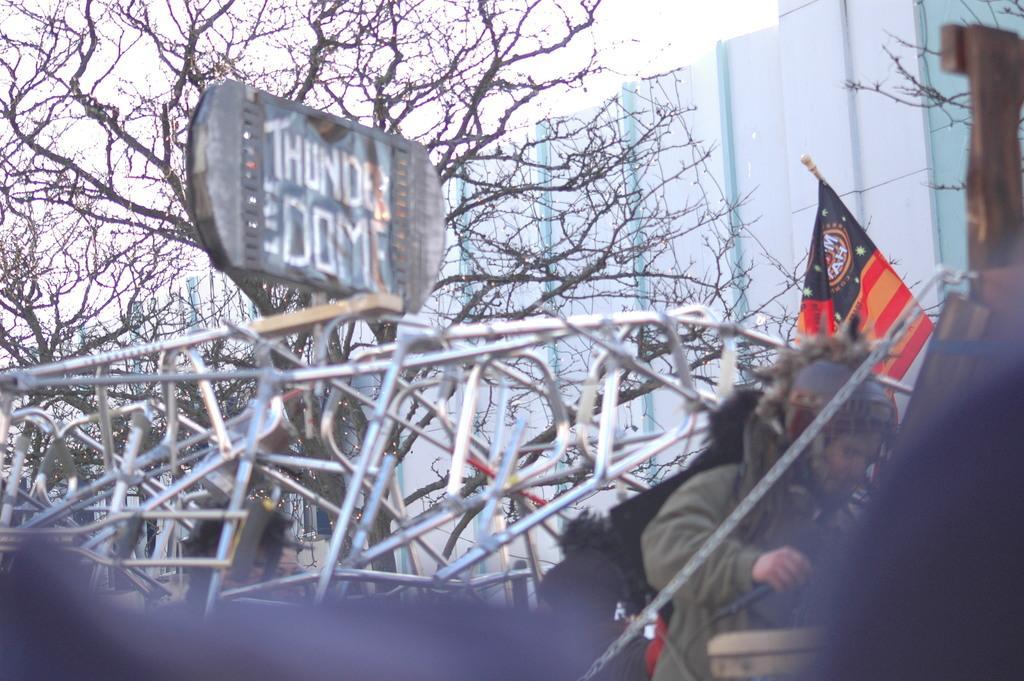Please provide a concise description of this image. In this image I can see in the middle there is a stainless frame. On the right side there is a person, this person wear a coat. There is the flag, at the back side there are trees and there is a building. 